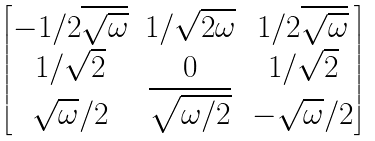Convert formula to latex. <formula><loc_0><loc_0><loc_500><loc_500>\begin{bmatrix} - 1 / 2 \overline { \sqrt { \omega } } & 1 / \sqrt { 2 \omega } & 1 / 2 \overline { \sqrt { \omega } } \\ 1 / \sqrt { 2 } & 0 & 1 / \sqrt { 2 } \\ \sqrt { \omega } / 2 & \overline { \sqrt { \omega / 2 } } & - \sqrt { \omega } / 2 \end{bmatrix}</formula> 